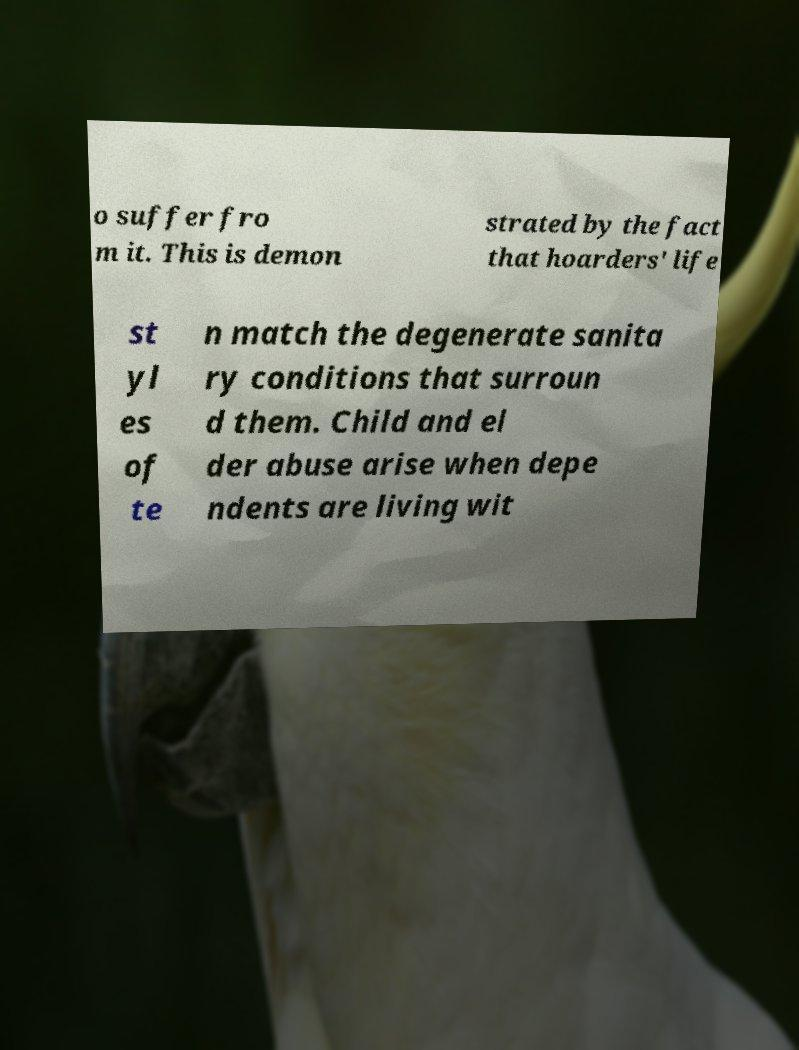What messages or text are displayed in this image? I need them in a readable, typed format. o suffer fro m it. This is demon strated by the fact that hoarders' life st yl es of te n match the degenerate sanita ry conditions that surroun d them. Child and el der abuse arise when depe ndents are living wit 